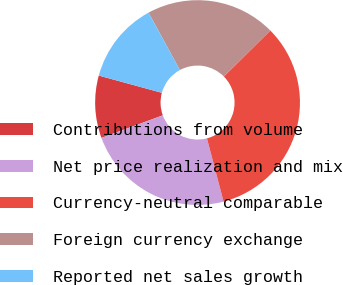Convert chart. <chart><loc_0><loc_0><loc_500><loc_500><pie_chart><fcel>Contributions from volume<fcel>Net price realization and mix<fcel>Currency-neutral comparable<fcel>Foreign currency exchange<fcel>Reported net sales growth<nl><fcel>9.86%<fcel>23.48%<fcel>33.33%<fcel>20.52%<fcel>12.81%<nl></chart> 